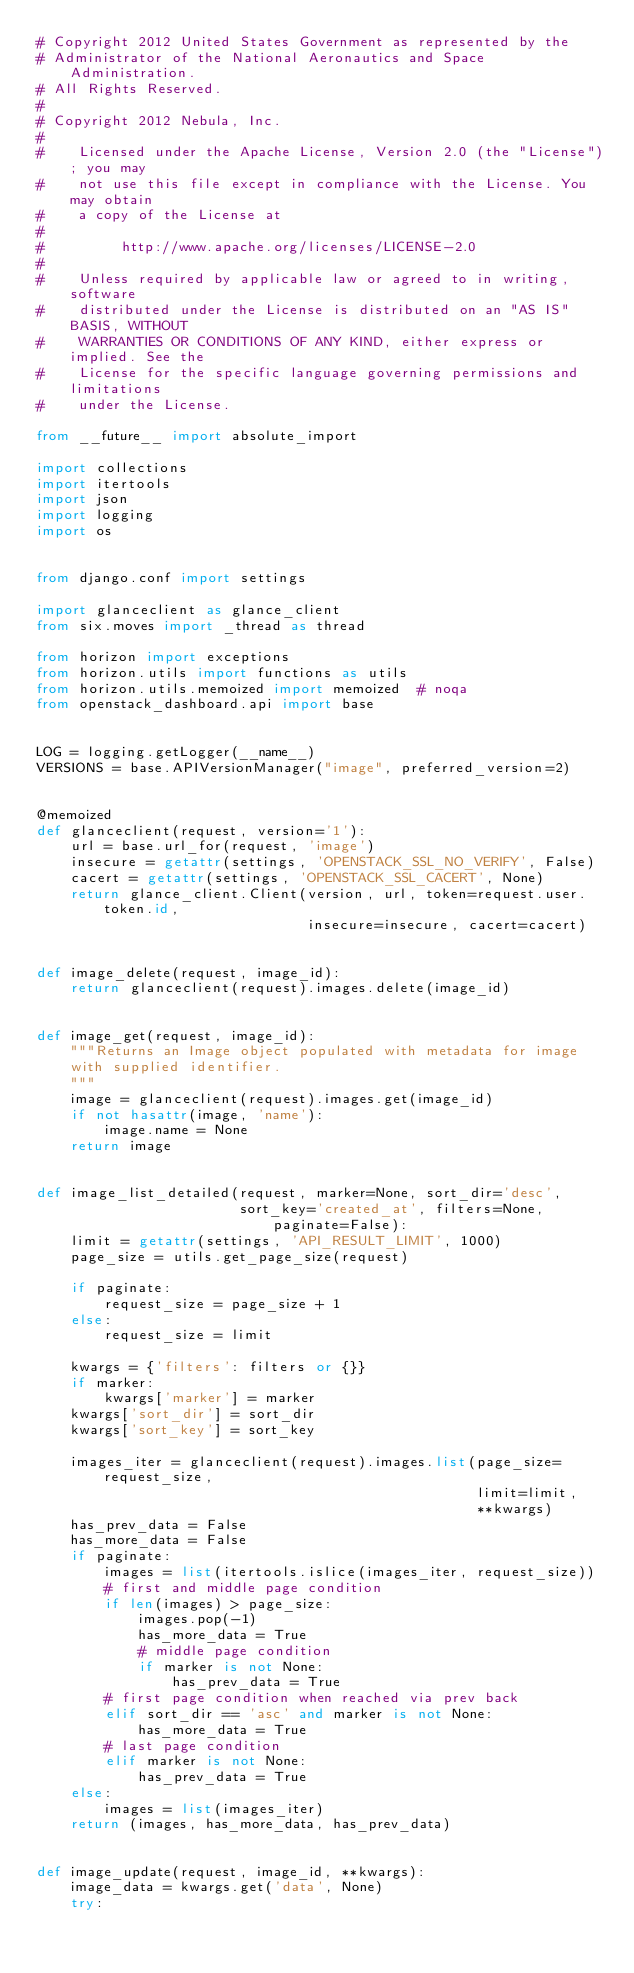Convert code to text. <code><loc_0><loc_0><loc_500><loc_500><_Python_># Copyright 2012 United States Government as represented by the
# Administrator of the National Aeronautics and Space Administration.
# All Rights Reserved.
#
# Copyright 2012 Nebula, Inc.
#
#    Licensed under the Apache License, Version 2.0 (the "License"); you may
#    not use this file except in compliance with the License. You may obtain
#    a copy of the License at
#
#         http://www.apache.org/licenses/LICENSE-2.0
#
#    Unless required by applicable law or agreed to in writing, software
#    distributed under the License is distributed on an "AS IS" BASIS, WITHOUT
#    WARRANTIES OR CONDITIONS OF ANY KIND, either express or implied. See the
#    License for the specific language governing permissions and limitations
#    under the License.

from __future__ import absolute_import

import collections
import itertools
import json
import logging
import os


from django.conf import settings

import glanceclient as glance_client
from six.moves import _thread as thread

from horizon import exceptions
from horizon.utils import functions as utils
from horizon.utils.memoized import memoized  # noqa
from openstack_dashboard.api import base


LOG = logging.getLogger(__name__)
VERSIONS = base.APIVersionManager("image", preferred_version=2)


@memoized
def glanceclient(request, version='1'):
    url = base.url_for(request, 'image')
    insecure = getattr(settings, 'OPENSTACK_SSL_NO_VERIFY', False)
    cacert = getattr(settings, 'OPENSTACK_SSL_CACERT', None)
    return glance_client.Client(version, url, token=request.user.token.id,
                                insecure=insecure, cacert=cacert)


def image_delete(request, image_id):
    return glanceclient(request).images.delete(image_id)


def image_get(request, image_id):
    """Returns an Image object populated with metadata for image
    with supplied identifier.
    """
    image = glanceclient(request).images.get(image_id)
    if not hasattr(image, 'name'):
        image.name = None
    return image


def image_list_detailed(request, marker=None, sort_dir='desc',
                        sort_key='created_at', filters=None, paginate=False):
    limit = getattr(settings, 'API_RESULT_LIMIT', 1000)
    page_size = utils.get_page_size(request)

    if paginate:
        request_size = page_size + 1
    else:
        request_size = limit

    kwargs = {'filters': filters or {}}
    if marker:
        kwargs['marker'] = marker
    kwargs['sort_dir'] = sort_dir
    kwargs['sort_key'] = sort_key

    images_iter = glanceclient(request).images.list(page_size=request_size,
                                                    limit=limit,
                                                    **kwargs)
    has_prev_data = False
    has_more_data = False
    if paginate:
        images = list(itertools.islice(images_iter, request_size))
        # first and middle page condition
        if len(images) > page_size:
            images.pop(-1)
            has_more_data = True
            # middle page condition
            if marker is not None:
                has_prev_data = True
        # first page condition when reached via prev back
        elif sort_dir == 'asc' and marker is not None:
            has_more_data = True
        # last page condition
        elif marker is not None:
            has_prev_data = True
    else:
        images = list(images_iter)
    return (images, has_more_data, has_prev_data)


def image_update(request, image_id, **kwargs):
    image_data = kwargs.get('data', None)
    try:</code> 